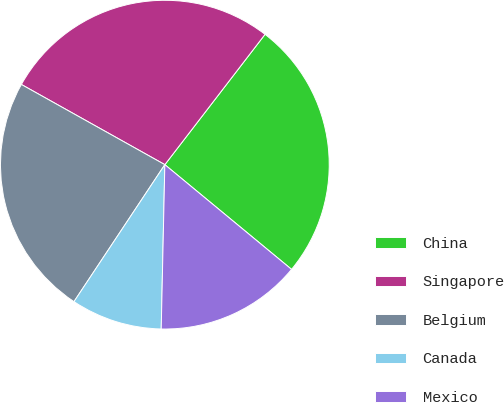Convert chart to OTSL. <chart><loc_0><loc_0><loc_500><loc_500><pie_chart><fcel>China<fcel>Singapore<fcel>Belgium<fcel>Canada<fcel>Mexico<nl><fcel>25.56%<fcel>27.32%<fcel>23.79%<fcel>8.97%<fcel>14.36%<nl></chart> 